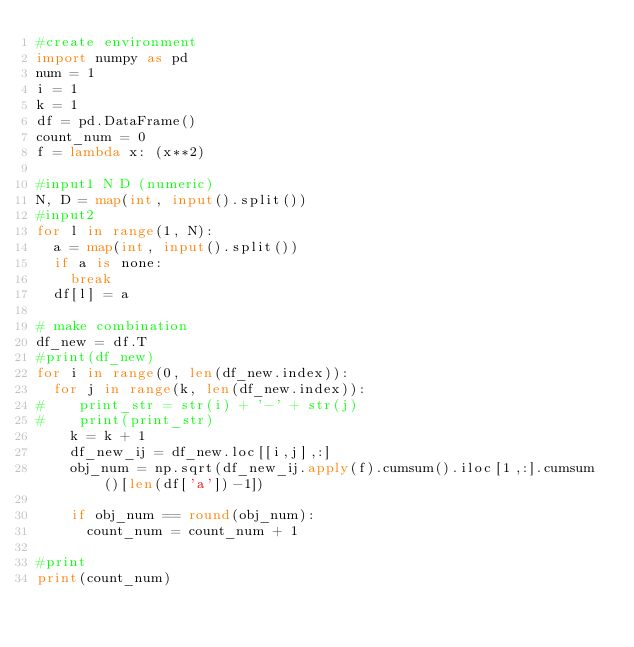<code> <loc_0><loc_0><loc_500><loc_500><_Python_>#create environment
import numpy as pd
num = 1
i = 1
k = 1
df = pd.DataFrame()
count_num = 0
f = lambda x: (x**2)

#input1 N D (numeric)
N, D = map(int, input().split())
#input2
for l in range(1, N):
  a = map(int, input().split())
  if a is none:
    break
  df[l] = a

# make combination
df_new = df.T
#print(df_new)
for i in range(0, len(df_new.index)):
  for j in range(k, len(df_new.index)):
#    print_str = str(i) + '-' + str(j)
#    print(print_str)
    k = k + 1
    df_new_ij = df_new.loc[[i,j],:]
    obj_num = np.sqrt(df_new_ij.apply(f).cumsum().iloc[1,:].cumsum()[len(df['a'])-1])
    
    if obj_num == round(obj_num):
      count_num = count_num + 1

#print
print(count_num)




</code> 